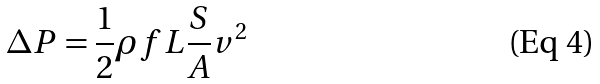Convert formula to latex. <formula><loc_0><loc_0><loc_500><loc_500>\Delta P = \frac { 1 } { 2 } \rho f L \frac { S } { A } v ^ { 2 }</formula> 